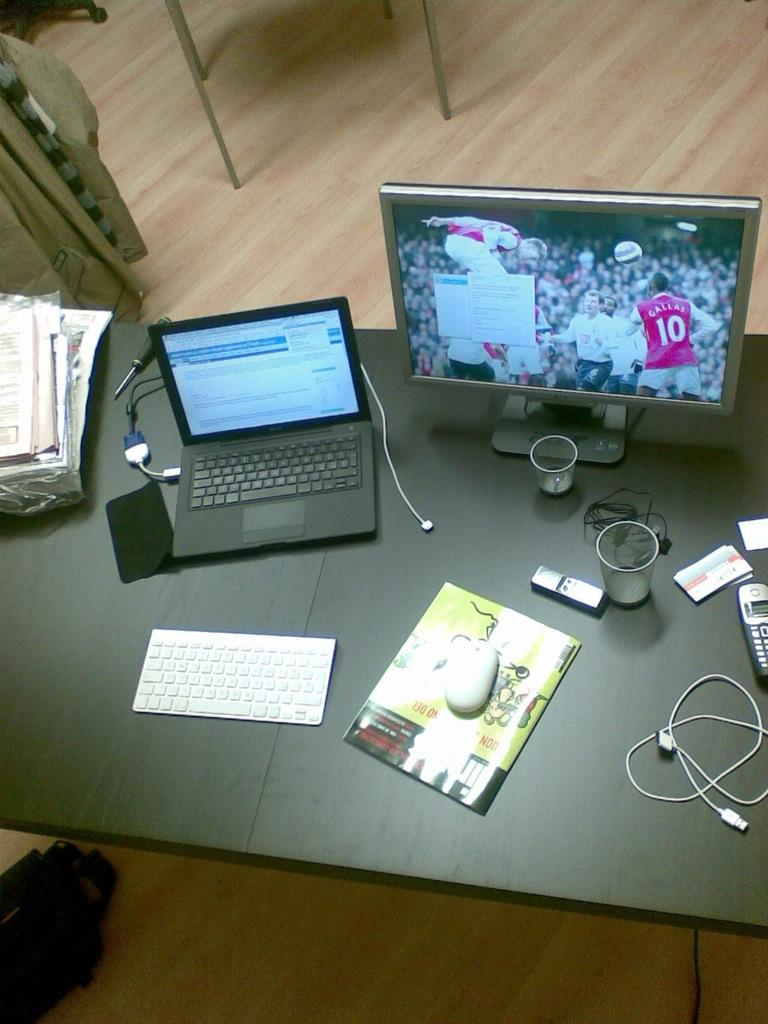Provide a one-sentence caption for the provided image. A athlete wearing a 10 jersey on a TV screen. 